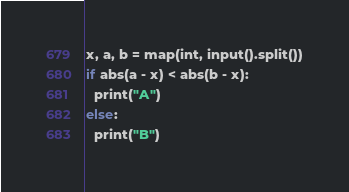Convert code to text. <code><loc_0><loc_0><loc_500><loc_500><_Python_>x, a, b = map(int, input().split())
if abs(a - x) < abs(b - x):
  print("A")
else:
  print("B")</code> 